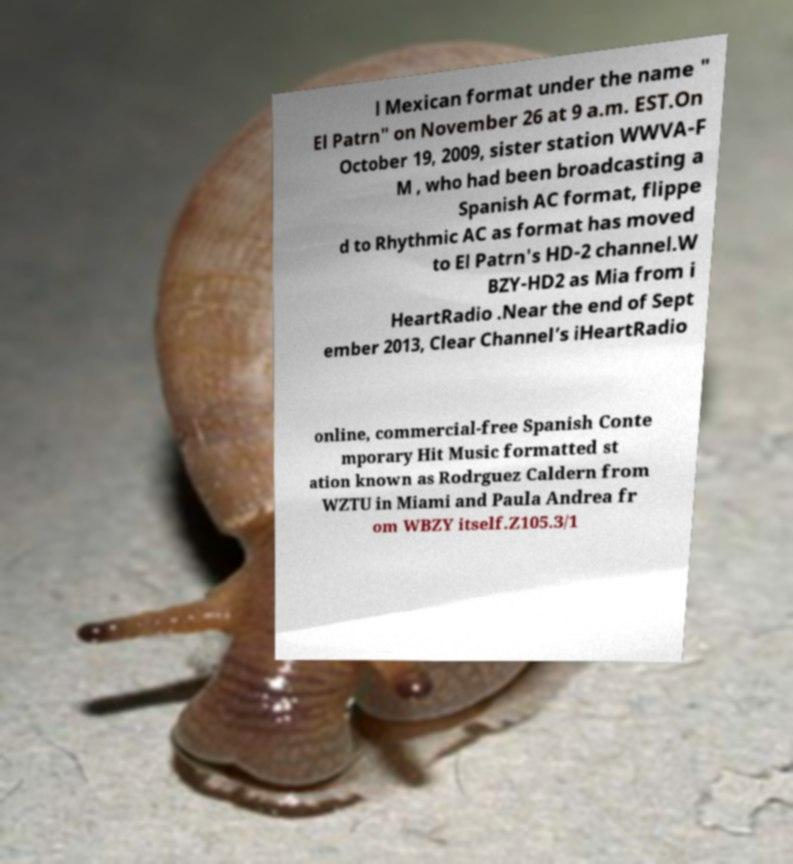There's text embedded in this image that I need extracted. Can you transcribe it verbatim? l Mexican format under the name " El Patrn" on November 26 at 9 a.m. EST.On October 19, 2009, sister station WWVA-F M , who had been broadcasting a Spanish AC format, flippe d to Rhythmic AC as format has moved to El Patrn's HD-2 channel.W BZY-HD2 as Mia from i HeartRadio .Near the end of Sept ember 2013, Clear Channel’s iHeartRadio online, commercial-free Spanish Conte mporary Hit Music formatted st ation known as Rodrguez Caldern from WZTU in Miami and Paula Andrea fr om WBZY itself.Z105.3/1 